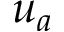<formula> <loc_0><loc_0><loc_500><loc_500>u _ { a }</formula> 